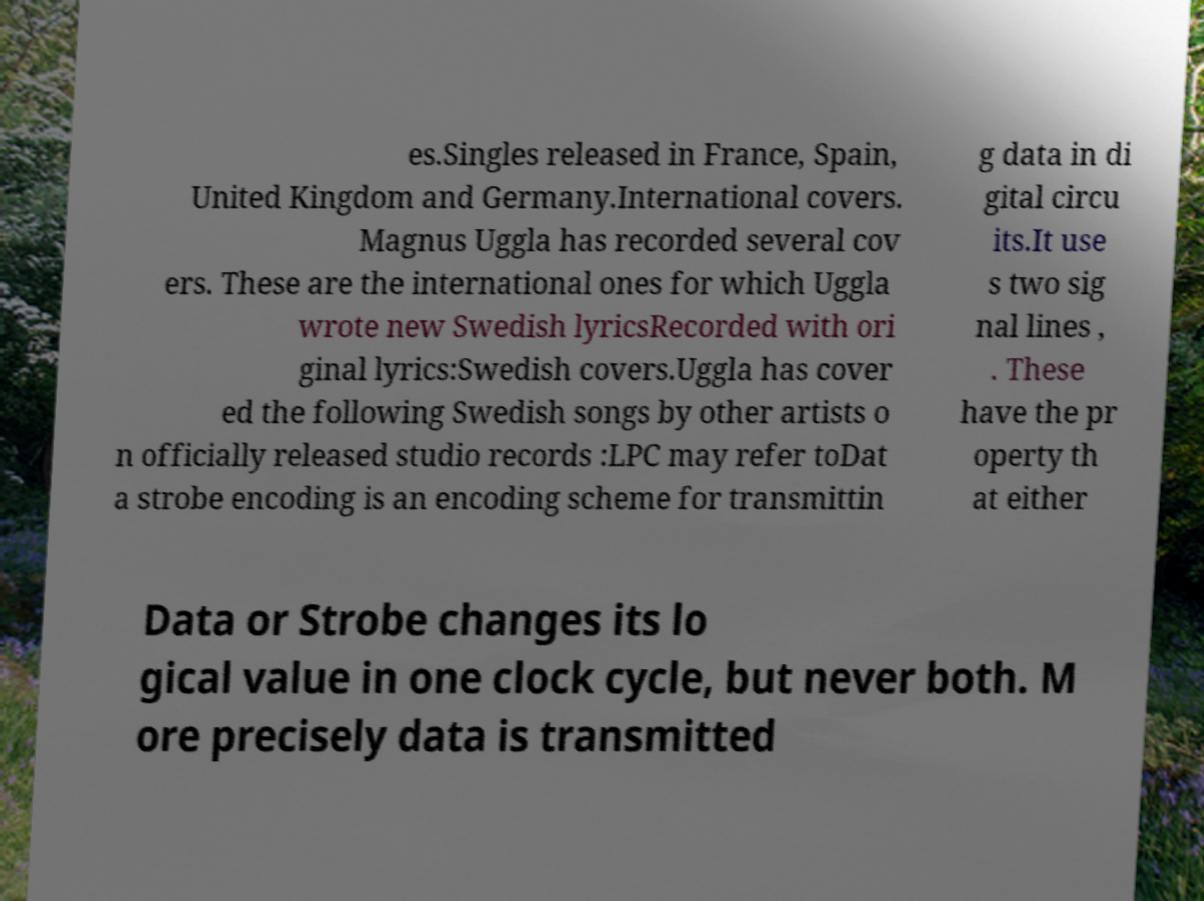I need the written content from this picture converted into text. Can you do that? es.Singles released in France, Spain, United Kingdom and Germany.International covers. Magnus Uggla has recorded several cov ers. These are the international ones for which Uggla wrote new Swedish lyricsRecorded with ori ginal lyrics:Swedish covers.Uggla has cover ed the following Swedish songs by other artists o n officially released studio records :LPC may refer toDat a strobe encoding is an encoding scheme for transmittin g data in di gital circu its.It use s two sig nal lines , . These have the pr operty th at either Data or Strobe changes its lo gical value in one clock cycle, but never both. M ore precisely data is transmitted 